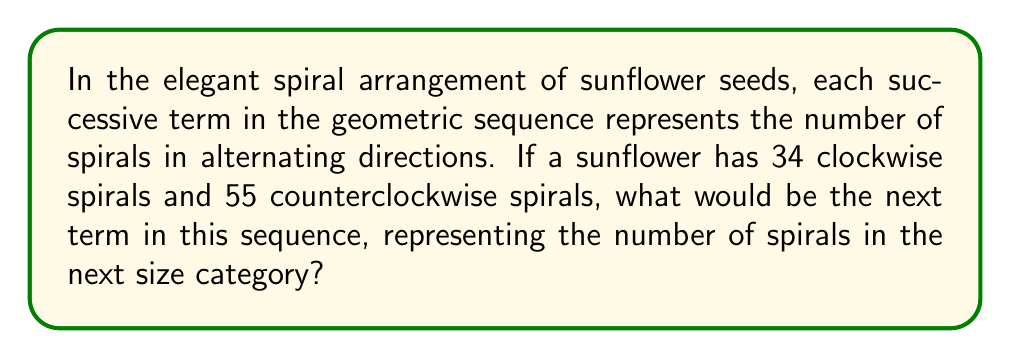Give your solution to this math problem. To solve this problem, we need to recognize the pattern in the given sequence and extend it. Let's approach this step-by-step:

1) First, we identify the given terms in the sequence:
   $a_1 = 34$ (clockwise spirals)
   $a_2 = 55$ (counterclockwise spirals)

2) In a geometric sequence, each term is a constant multiple of the previous term. Let's call this constant $r$. We can find $r$ by dividing $a_2$ by $a_1$:

   $r = \frac{a_2}{a_1} = \frac{55}{34} \approx 1.6176$

3) This ratio is very close to the golden ratio, $\phi = \frac{1+\sqrt{5}}{2} \approx 1.6180$, which is often observed in nature's patterns, including sunflower seed arrangements.

4) To find the next term, $a_3$, we multiply $a_2$ by $r$:

   $a_3 = a_2 \cdot r = 55 \cdot \frac{55}{34} = \frac{55^2}{34}$

5) Simplifying:
   $a_3 = \frac{3025}{34} = 89$

6) We can verify this result by noting that 89 is the next number in the Fibonacci sequence after 34 and 55, which often appears in natural spirals due to its relationship with the golden ratio.

Therefore, the next term in the sequence, representing the number of spirals in the next size category, would be 89.
Answer: 89 